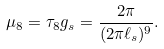<formula> <loc_0><loc_0><loc_500><loc_500>\mu _ { 8 } = \tau _ { 8 } g _ { s } = \frac { 2 \pi } { ( 2 \pi \ell _ { s } ) ^ { 9 } } .</formula> 